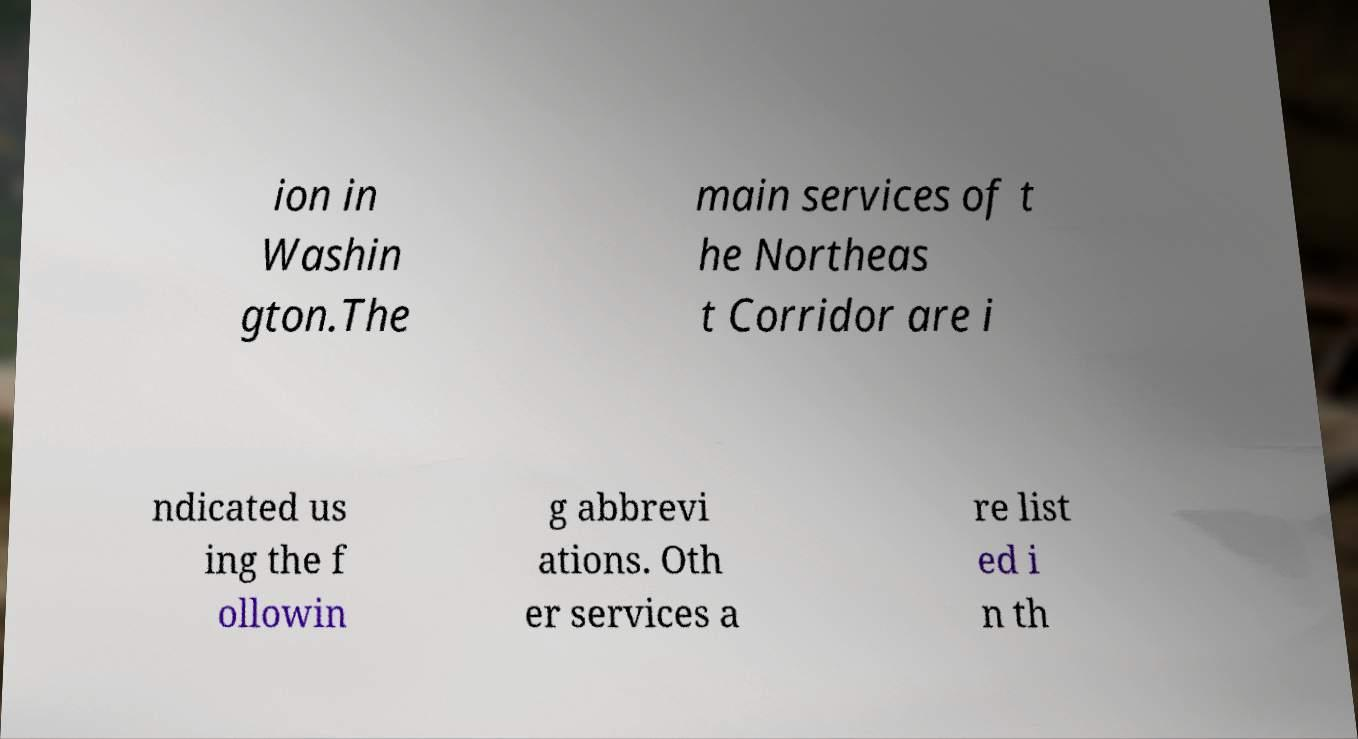Please identify and transcribe the text found in this image. ion in Washin gton.The main services of t he Northeas t Corridor are i ndicated us ing the f ollowin g abbrevi ations. Oth er services a re list ed i n th 